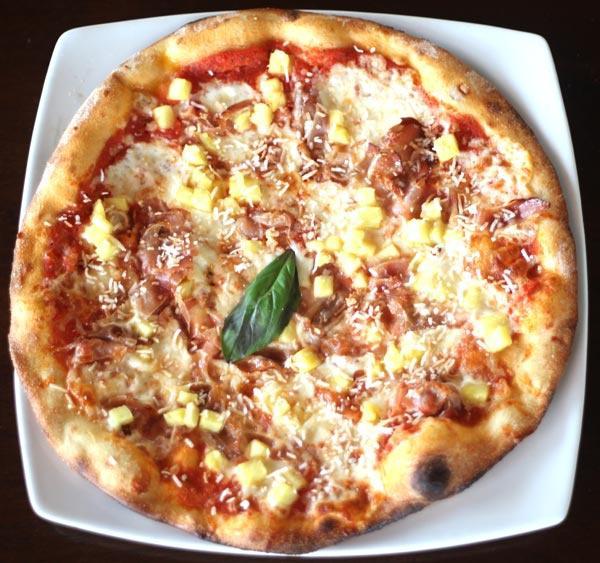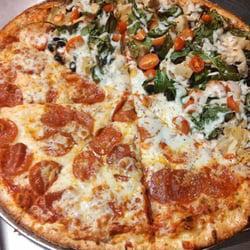The first image is the image on the left, the second image is the image on the right. Analyze the images presented: Is the assertion "The left image features one sliced pizza on a round silver tray, with no slices missing and with similar toppings across the whole pizza." valid? Answer yes or no. No. The first image is the image on the left, the second image is the image on the right. Examine the images to the left and right. Is the description "Two pizzas have green toppings covering at least a small portion of the pizza." accurate? Answer yes or no. Yes. 